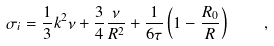Convert formula to latex. <formula><loc_0><loc_0><loc_500><loc_500>\sigma _ { i } = \frac { 1 } { 3 } k ^ { 2 } \nu + \frac { 3 } { 4 } \frac { \nu } { R ^ { 2 } } + \frac { 1 } { 6 \tau } \left ( 1 - \frac { R _ { 0 } } { R } \right ) \quad ,</formula> 